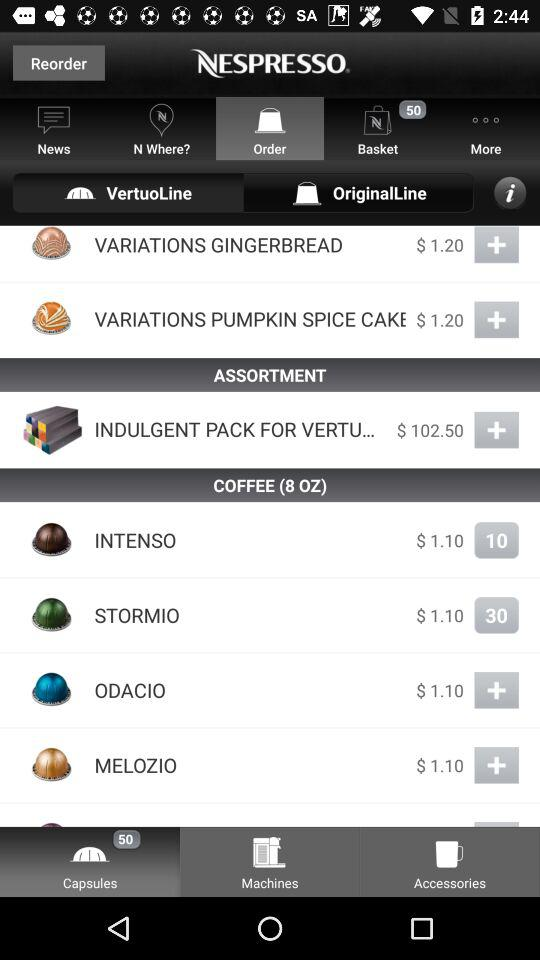What is the price of "INTENSO"? The price of "INTENSO" is $1.10. 